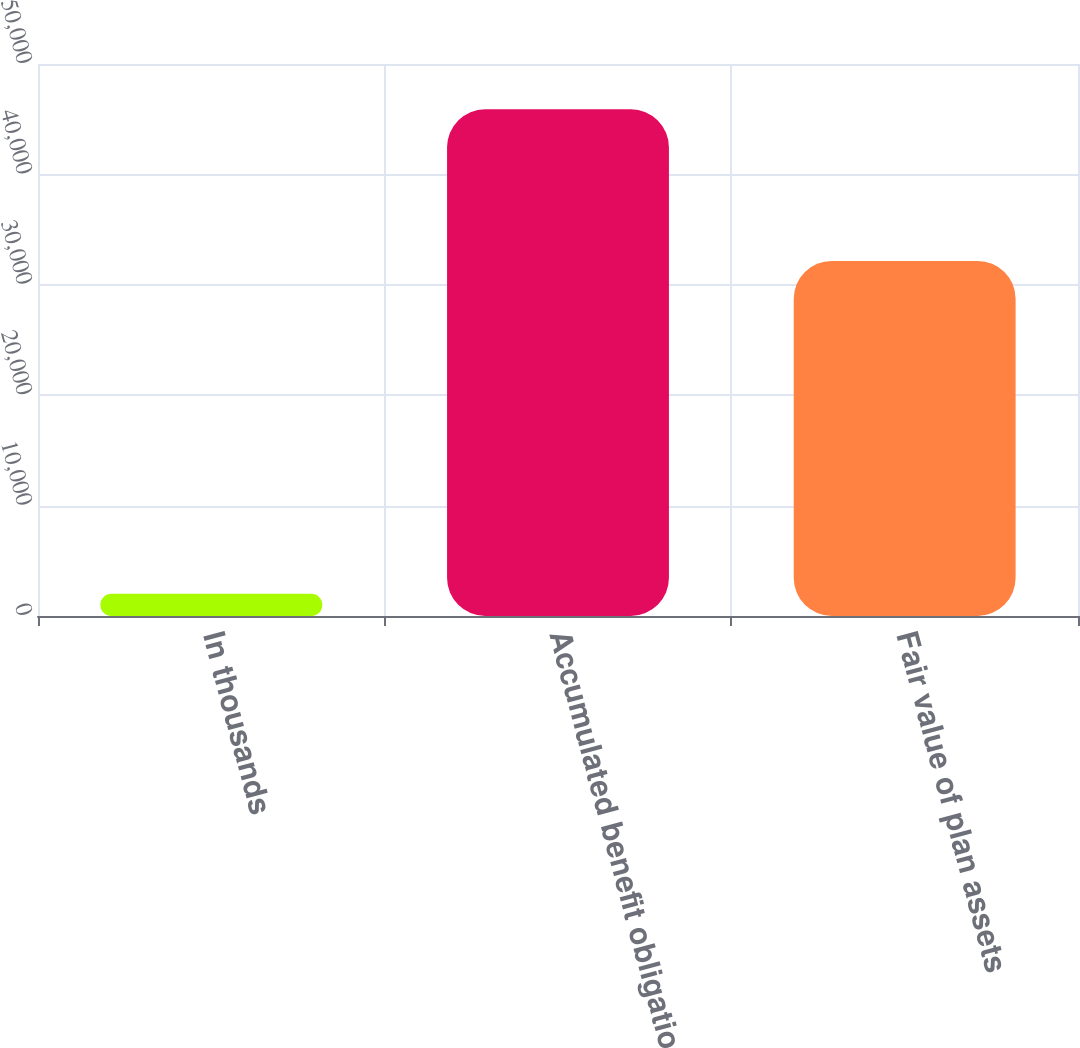<chart> <loc_0><loc_0><loc_500><loc_500><bar_chart><fcel>In thousands<fcel>Accumulated benefit obligation<fcel>Fair value of plan assets<nl><fcel>2008<fcel>45899<fcel>32164<nl></chart> 